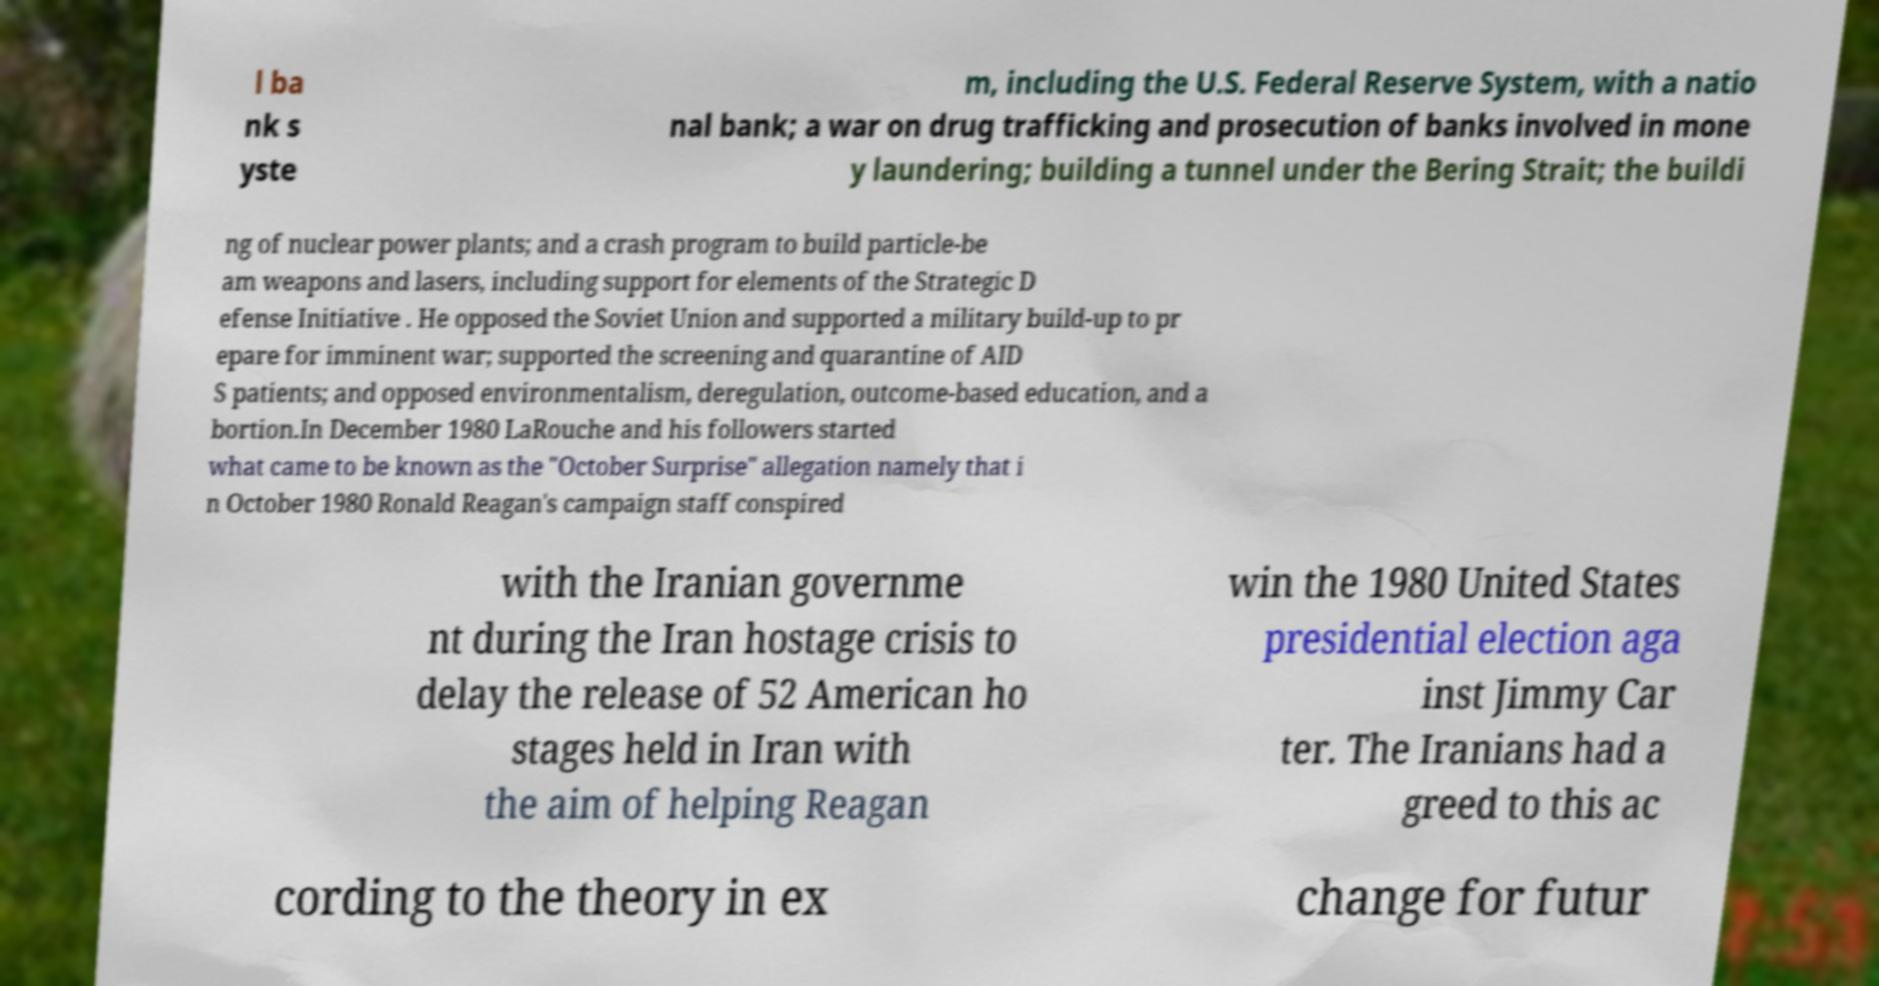What messages or text are displayed in this image? I need them in a readable, typed format. l ba nk s yste m, including the U.S. Federal Reserve System, with a natio nal bank; a war on drug trafficking and prosecution of banks involved in mone y laundering; building a tunnel under the Bering Strait; the buildi ng of nuclear power plants; and a crash program to build particle-be am weapons and lasers, including support for elements of the Strategic D efense Initiative . He opposed the Soviet Union and supported a military build-up to pr epare for imminent war; supported the screening and quarantine of AID S patients; and opposed environmentalism, deregulation, outcome-based education, and a bortion.In December 1980 LaRouche and his followers started what came to be known as the "October Surprise" allegation namely that i n October 1980 Ronald Reagan's campaign staff conspired with the Iranian governme nt during the Iran hostage crisis to delay the release of 52 American ho stages held in Iran with the aim of helping Reagan win the 1980 United States presidential election aga inst Jimmy Car ter. The Iranians had a greed to this ac cording to the theory in ex change for futur 